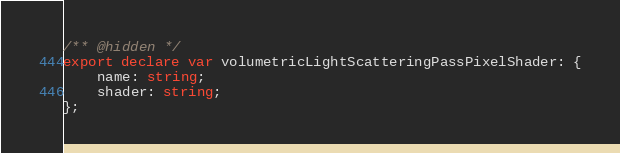Convert code to text. <code><loc_0><loc_0><loc_500><loc_500><_TypeScript_>/** @hidden */
export declare var volumetricLightScatteringPassPixelShader: {
    name: string;
    shader: string;
};
</code> 